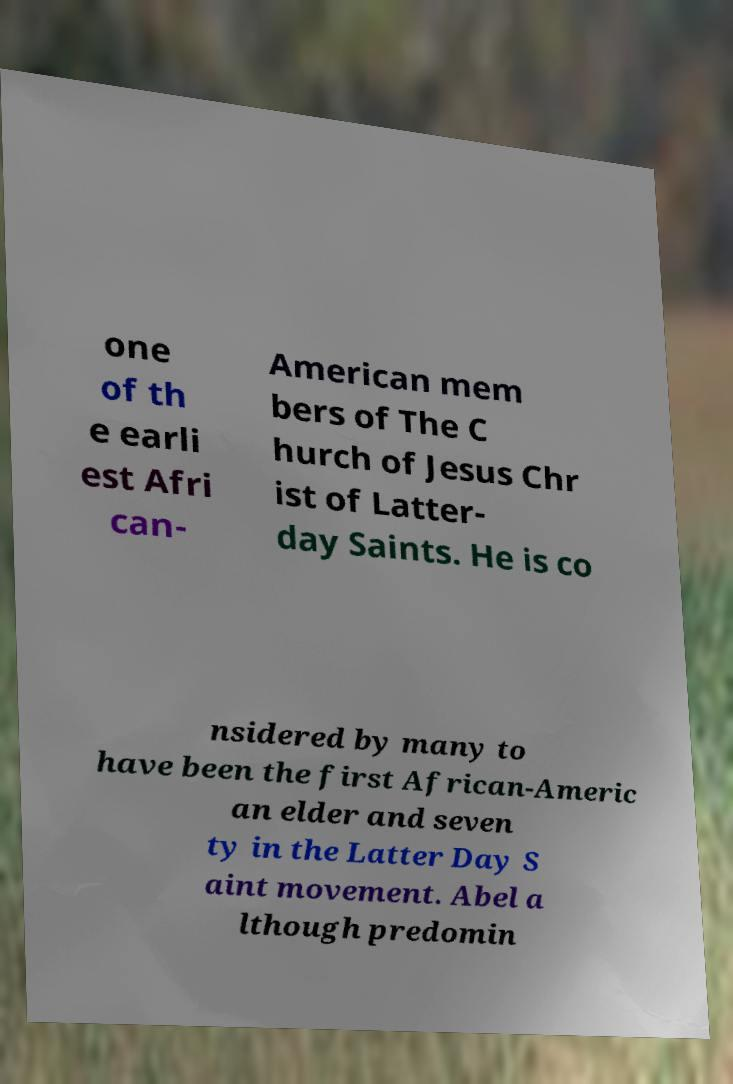Could you assist in decoding the text presented in this image and type it out clearly? one of th e earli est Afri can- American mem bers of The C hurch of Jesus Chr ist of Latter- day Saints. He is co nsidered by many to have been the first African-Americ an elder and seven ty in the Latter Day S aint movement. Abel a lthough predomin 